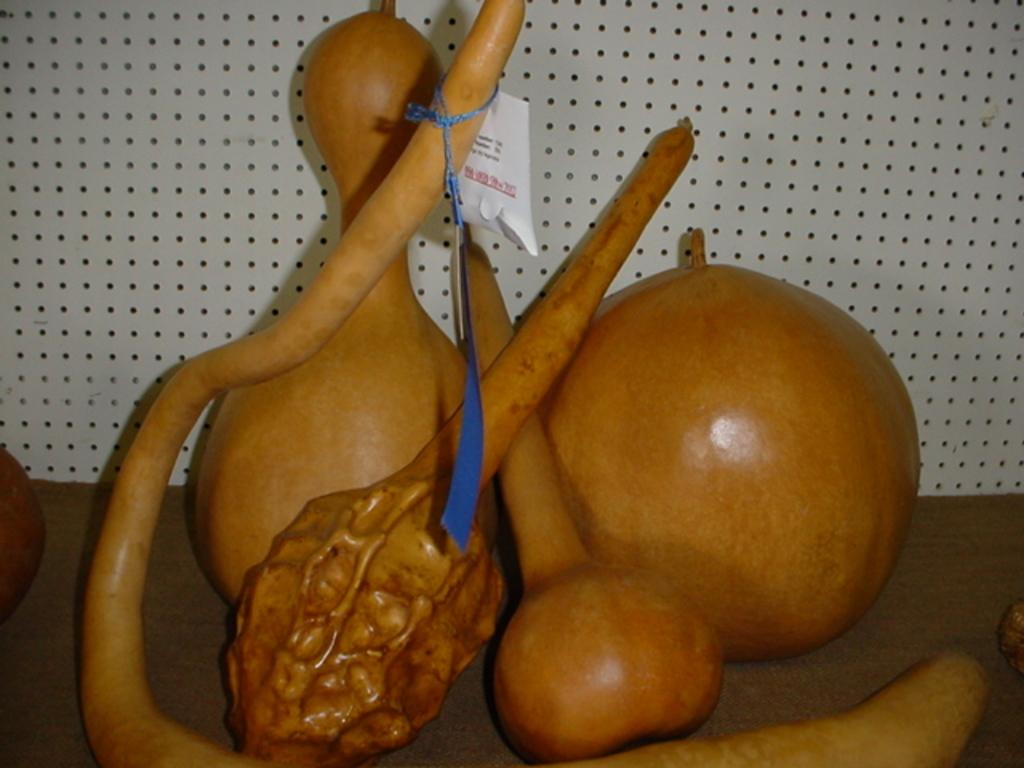What type of pencil is the minister using to shade the image? There is no pencil, minister, or shading activity present in the image. 